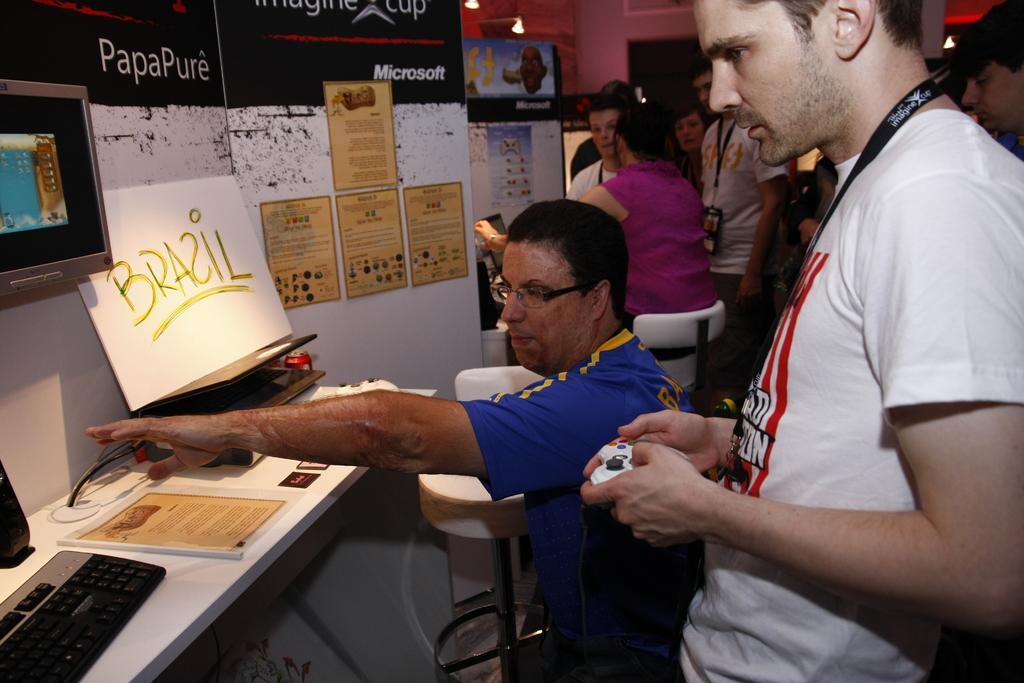Can you describe this image briefly? In this picture few persons standing. These two persons sitting on the chair. This is table. On the table we can see keyboard,book,board. On the background we can see wall,posters. This person hold remote. 